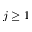Convert formula to latex. <formula><loc_0><loc_0><loc_500><loc_500>j \geq 1</formula> 